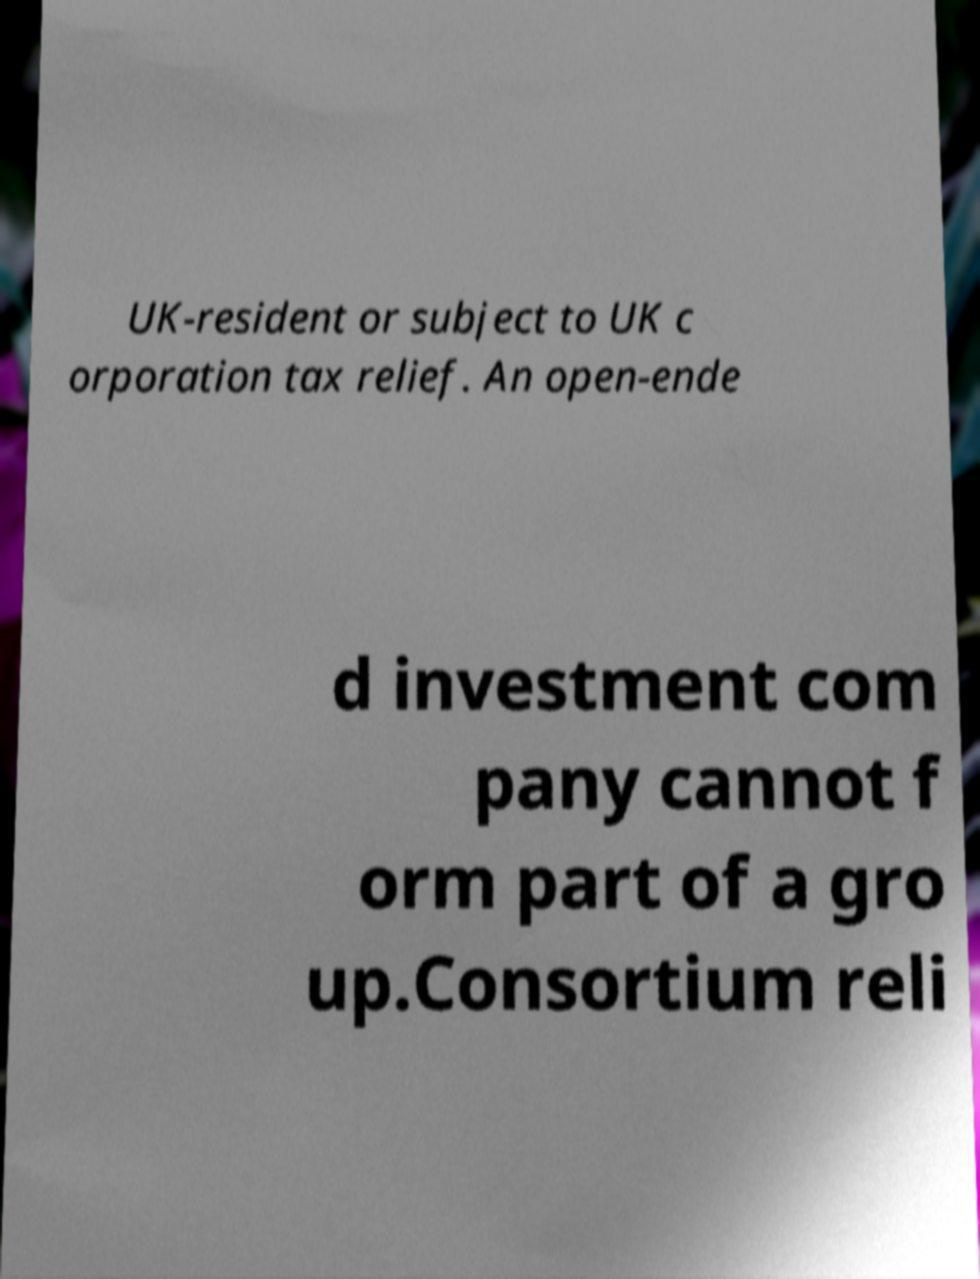Can you read and provide the text displayed in the image?This photo seems to have some interesting text. Can you extract and type it out for me? UK-resident or subject to UK c orporation tax relief. An open-ende d investment com pany cannot f orm part of a gro up.Consortium reli 